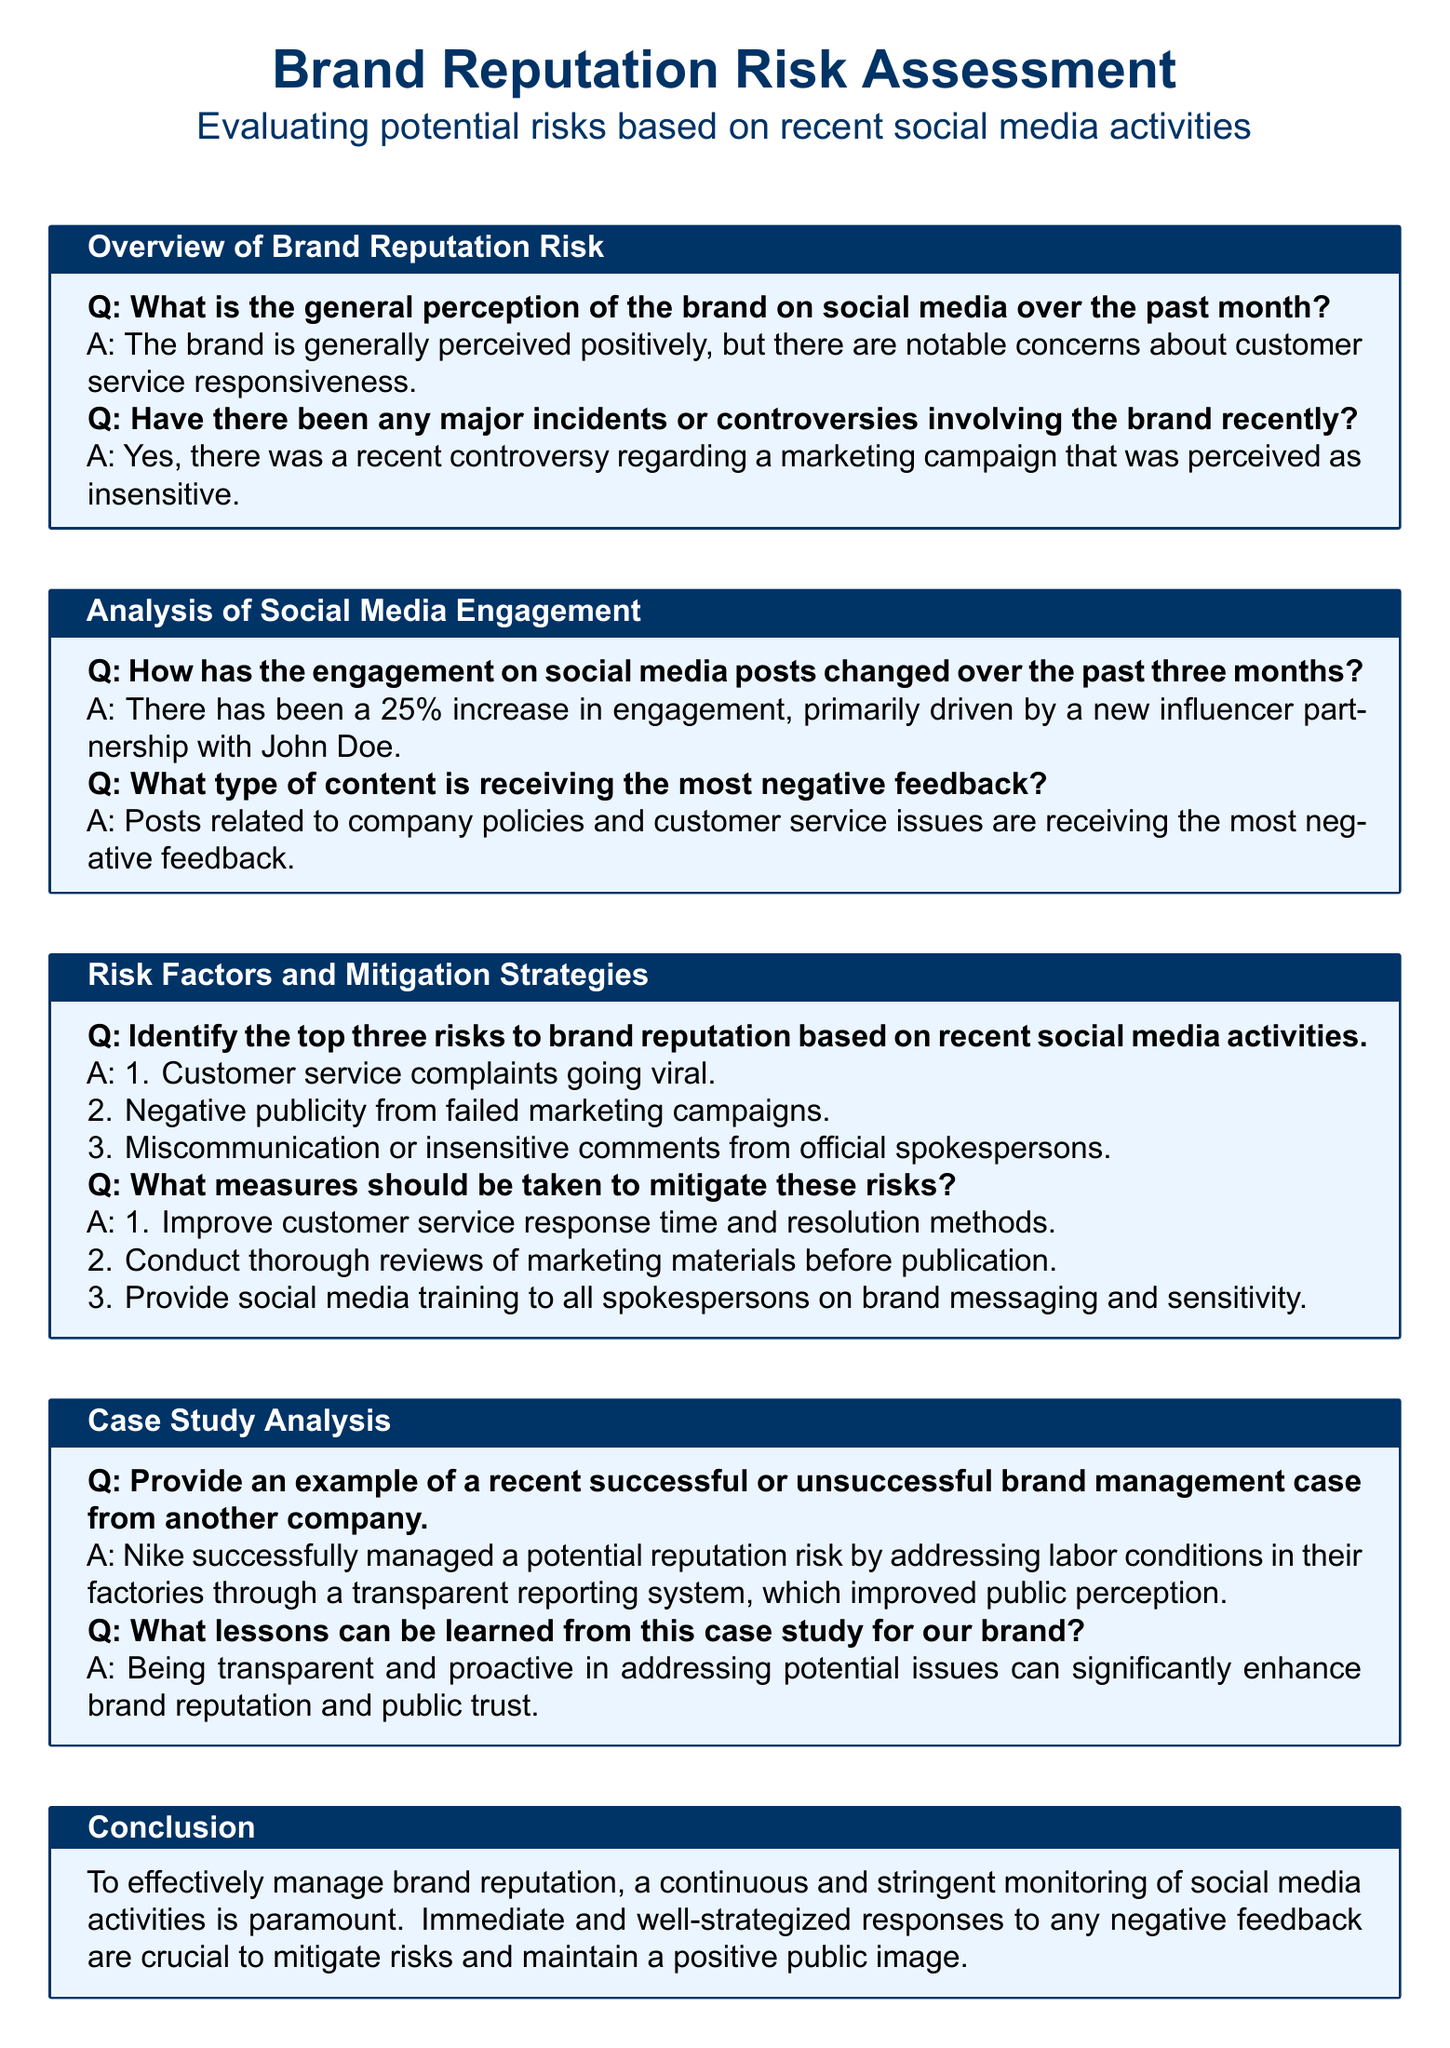What is the overall perception of the brand on social media? The document states that the brand is generally perceived positively, but there are notable concerns about customer service responsiveness.
Answer: positively What percentage increase in social media engagement was observed? The document indicates that there has been a 25% increase in engagement.
Answer: 25% What is one type of content receiving negative feedback? The document mentions that posts related to company policies and customer service issues are receiving the most negative feedback.
Answer: company policies Name one of the top three risks to brand reputation. The document lists several risks, including customer service complaints going viral.
Answer: customer service complaints What measure is suggested to mitigate risks? The document suggests improving customer service response time and resolution methods as a measure to mitigate risks.
Answer: improve customer service What company successfully managed a reputation risk? The document provides the example of Nike successfully managing a potential reputation risk regarding labor conditions.
Answer: Nike What lesson can be learned from Nike's case? The document indicates that being transparent and proactive in addressing potential issues can enhance brand reputation.
Answer: transparency and proactivity How often should social media activities be monitored? The document emphasizes that continuous monitoring of social media activities is paramount.
Answer: continuously 